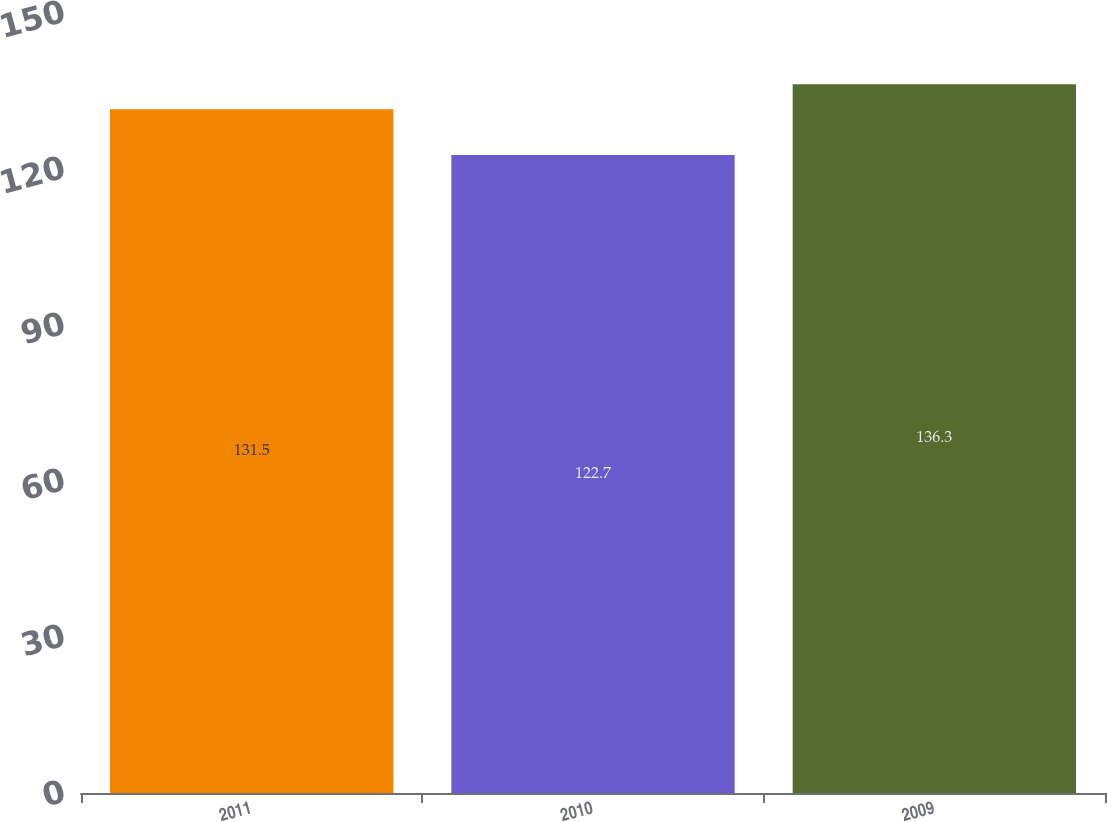<chart> <loc_0><loc_0><loc_500><loc_500><bar_chart><fcel>2011<fcel>2010<fcel>2009<nl><fcel>131.5<fcel>122.7<fcel>136.3<nl></chart> 